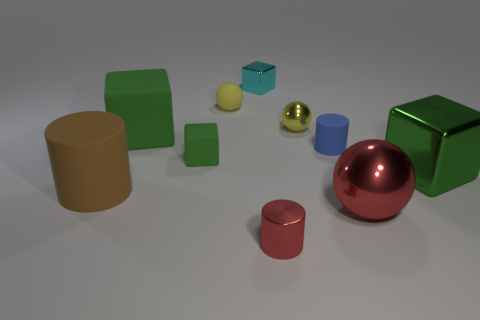Subtract all small green matte blocks. How many blocks are left? 3 Subtract all green blocks. How many blocks are left? 1 Subtract all blocks. How many objects are left? 6 Subtract all shiny things. Subtract all green matte objects. How many objects are left? 3 Add 6 tiny cyan metal blocks. How many tiny cyan metal blocks are left? 7 Add 5 spheres. How many spheres exist? 8 Subtract 0 blue cubes. How many objects are left? 10 Subtract 1 blocks. How many blocks are left? 3 Subtract all gray cylinders. Subtract all blue blocks. How many cylinders are left? 3 Subtract all gray blocks. How many purple cylinders are left? 0 